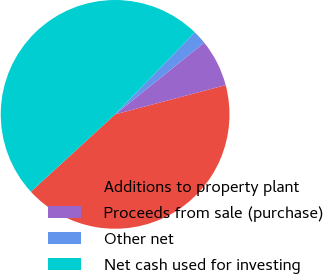<chart> <loc_0><loc_0><loc_500><loc_500><pie_chart><fcel>Additions to property plant<fcel>Proceeds from sale (purchase)<fcel>Other net<fcel>Net cash used for investing<nl><fcel>42.3%<fcel>6.67%<fcel>1.95%<fcel>49.08%<nl></chart> 